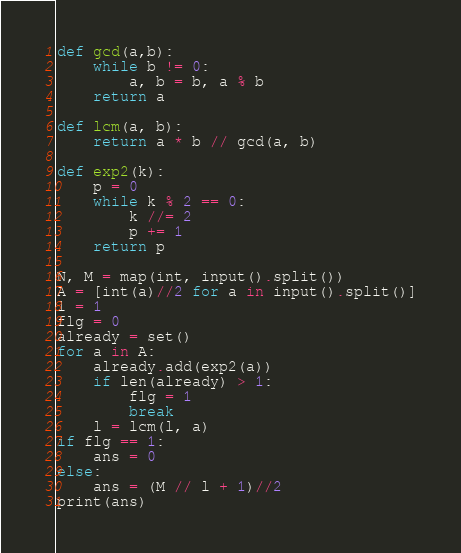Convert code to text. <code><loc_0><loc_0><loc_500><loc_500><_Python_>def gcd(a,b):
    while b != 0:
        a, b = b, a % b
    return a

def lcm(a, b):
    return a * b // gcd(a, b)

def exp2(k):
    p = 0
    while k % 2 == 0:
        k //= 2
        p += 1
    return p

N, M = map(int, input().split())
A = [int(a)//2 for a in input().split()]
l = 1
flg = 0
already = set()
for a in A:
    already.add(exp2(a))
    if len(already) > 1:
        flg = 1
        break
    l = lcm(l, a)
if flg == 1:
    ans = 0
else:
    ans = (M // l + 1)//2
print(ans)
</code> 